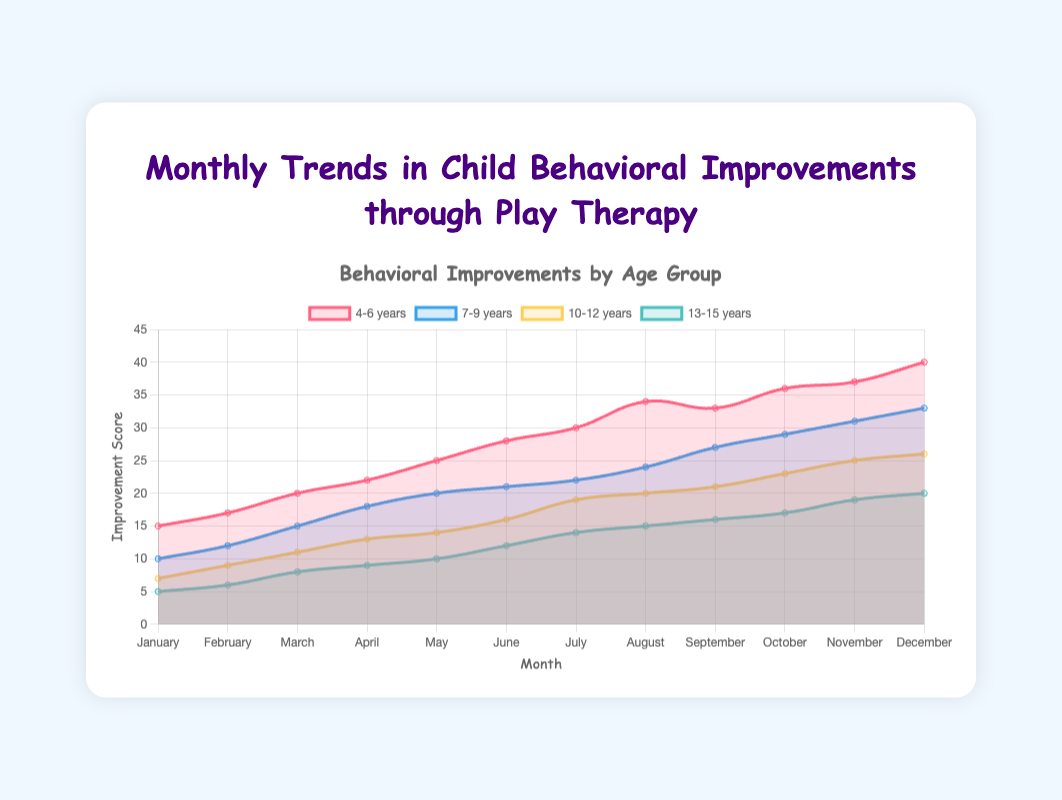What is the title of the chart? The title of the chart is displayed at the top and it reads "Monthly Trends in Child Behavioral Improvements through Play Therapy".
Answer: Monthly Trends in Child Behavioral Improvements through Play Therapy During which month did the 4-6 years age group see the highest improvement? The area chart shows the 4-6 years age group reached its highest improvement in December with a score of 40.
Answer: December Which age group experienced the lowest starting improvement in January? By looking at the starting points on the chart for each age group in January, the 13-15 years age group has the lowest improvement score of 5.
Answer: 13-15 years What is the improvement range for the 7-9 years age group throughout the year? To find the range, subtract the minimum improvement score from the maximum for the 7-9 years age group: 33 (December) - 10 (January) = 23.
Answer: 23 Which age group showed the most consistent improvement trend over the year? By examining the smoothness and slope consistency of the lines, the 10-12 years age group demonstrated a more steady and consistent increase in their improvement scores.
Answer: 10-12 years Between which months did the 4-6 years age group show the steepest increase in improvements? Look for the steepest slope in the 4-6 years line. The steepest increase occurred between July and August where the score rises rapidly from 30 to 34.
Answer: July to August How many age groups showed an improvement score above 30 in November? In November, observe the scores of each age group. Both the 4-6 years (37) and 7-9 years (31) age groups have improvement scores above 30.
Answer: Two In which month did the 10-12 years age group see its first improvement score above 20? The 10-12 years line first crosses above the value 20 in August.
Answer: August Compare the improvements in May between the age groups 4-6 years and 13-15 years. In May, the improvement score for the 4-6 years age group is 25 whereas for the 13-15 years age group, it is 10.
Answer: 4-6 years (25), 13-15 years (10) Which month did all age groups see an increase in their improvements compared to the previous month? By observing each line, we can see that from April to May, all age groups saw an increase in their improvement scores compared to April.
Answer: May 